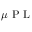<formula> <loc_0><loc_0><loc_500><loc_500>\mu P L</formula> 